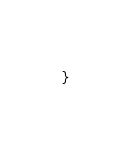Convert code to text. <code><loc_0><loc_0><loc_500><loc_500><_Java_>}
</code> 